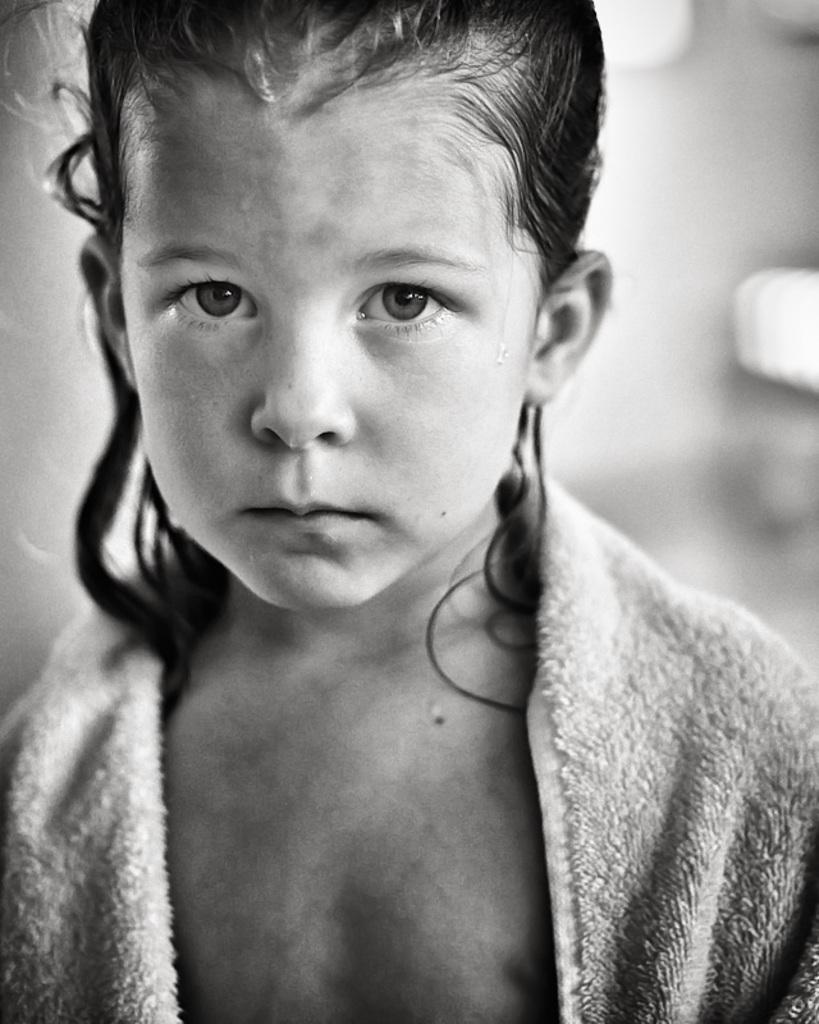What is the color scheme of the image? The image is black and white. Who is the main subject in the image? There is a girl in the image. What is the girl wearing or holding in the image? The girl is partially covered by a towel. Can you describe the background of the image? The background of the image is blurred. What type of wound can be seen on the girl's leg in the image? There is no wound visible on the girl's leg in the image, as it is black and white and the girl is partially covered by a towel. 